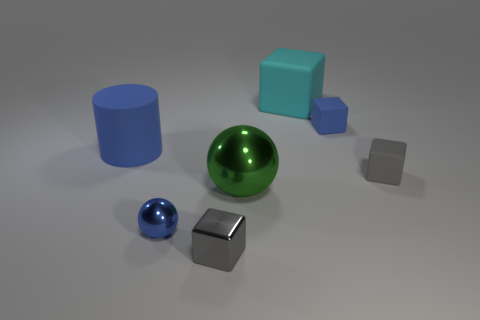Are there any other things that have the same shape as the big metal thing?
Your answer should be compact. Yes. Is the number of rubber cylinders that are in front of the metal cube greater than the number of gray metal spheres?
Offer a very short reply. No. Are there any matte blocks in front of the tiny gray matte object?
Your answer should be compact. No. Is the size of the gray rubber thing the same as the green metallic sphere?
Keep it short and to the point. No. What size is the cyan matte thing that is the same shape as the gray metallic object?
Offer a terse response. Large. What is the material of the small blue object behind the small matte object that is in front of the big blue cylinder?
Provide a succinct answer. Rubber. Is the shape of the green object the same as the big blue matte thing?
Ensure brevity in your answer.  No. How many blue things are behind the tiny blue sphere and on the left side of the large cyan rubber object?
Your answer should be very brief. 1. Is the number of blue cubes that are in front of the gray metallic object the same as the number of small blue rubber things in front of the small blue rubber thing?
Make the answer very short. Yes. Does the cube left of the big green object have the same size as the gray block behind the large green shiny thing?
Your response must be concise. Yes. 